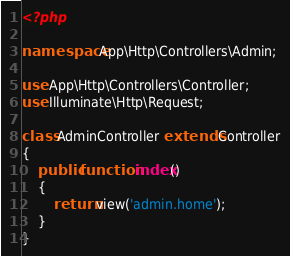Convert code to text. <code><loc_0><loc_0><loc_500><loc_500><_PHP_><?php

namespace App\Http\Controllers\Admin;

use App\Http\Controllers\Controller;
use Illuminate\Http\Request;

class AdminController extends Controller
{
    public function index()
    {
        return view('admin.home');
    }
}</code> 